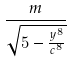<formula> <loc_0><loc_0><loc_500><loc_500>\frac { m } { \sqrt { 5 - \frac { y ^ { 8 } } { c ^ { 8 } } } }</formula> 